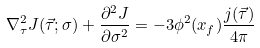<formula> <loc_0><loc_0><loc_500><loc_500>\nabla _ { \tau } ^ { 2 } J ( \vec { \tau } ; \sigma ) + \frac { \partial ^ { 2 } J } { \partial \sigma ^ { 2 } } = - 3 \phi ^ { 2 } ( x _ { f } ) \frac { j ( \vec { \tau } ) } { 4 \pi } \,</formula> 